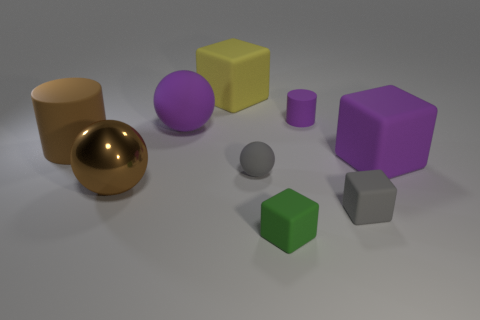Is there any other thing that is the same material as the big brown ball?
Ensure brevity in your answer.  No. What number of gray rubber objects are left of the large brown rubber thing?
Provide a short and direct response. 0. Are there fewer gray matte objects than large matte things?
Keep it short and to the point. Yes. There is a matte thing that is behind the big purple sphere and left of the tiny green cube; how big is it?
Ensure brevity in your answer.  Large. There is a large block on the left side of the small green block; is it the same color as the metallic sphere?
Offer a terse response. No. Are there fewer big shiny spheres on the left side of the big shiny sphere than large rubber things?
Offer a terse response. Yes. There is a small purple object that is the same material as the purple block; what is its shape?
Keep it short and to the point. Cylinder. Do the big yellow object and the small cylinder have the same material?
Your response must be concise. Yes. Is the number of brown cylinders that are in front of the big purple block less than the number of brown metallic balls behind the tiny gray matte sphere?
Ensure brevity in your answer.  No. The rubber cube that is the same color as the small rubber cylinder is what size?
Your answer should be very brief. Large. 